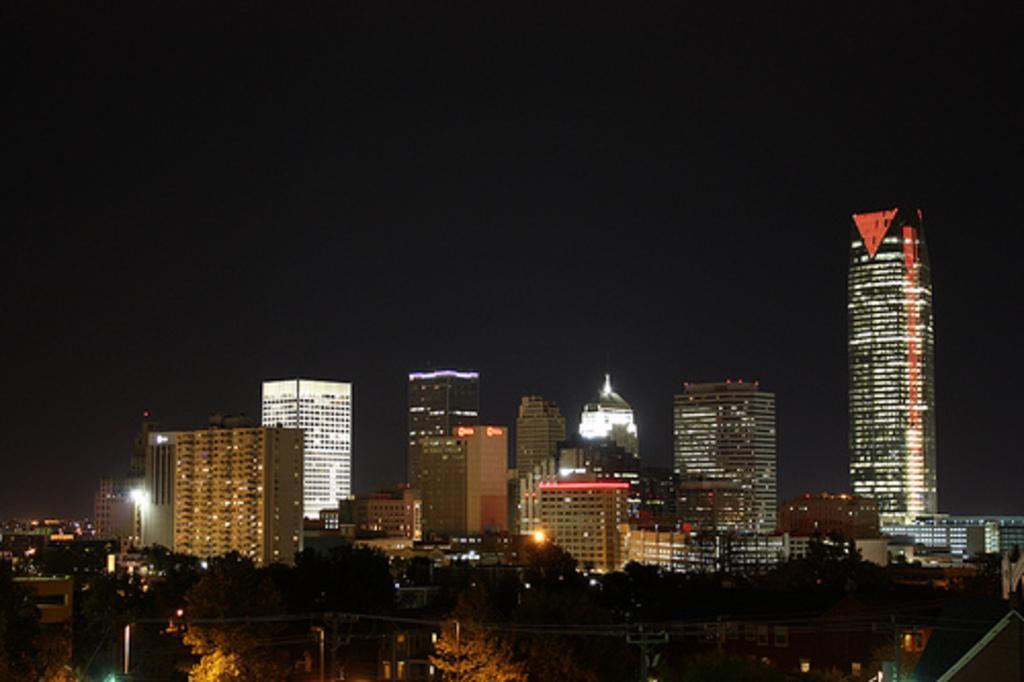Can you describe this image briefly? In this picture there are buildings in the center of the image and there are trees and water at the bottom side of the image. 